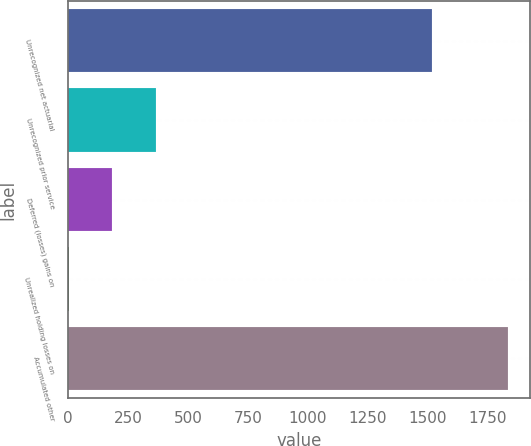Convert chart to OTSL. <chart><loc_0><loc_0><loc_500><loc_500><bar_chart><fcel>Unrecognized net actuarial<fcel>Unrecognized prior service<fcel>Deferred (losses) gains on<fcel>Unrealized holding losses on<fcel>Accumulated other<nl><fcel>1516<fcel>369<fcel>186<fcel>3<fcel>1833<nl></chart> 